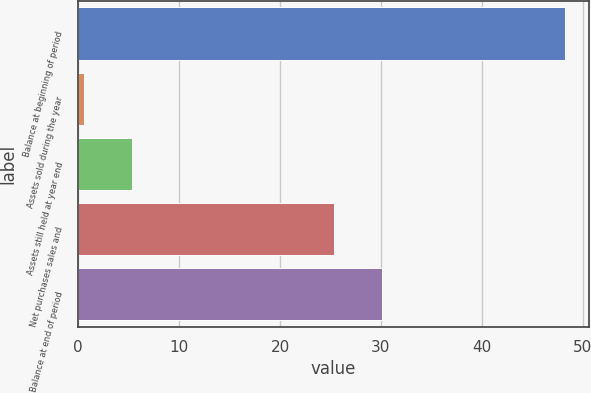Convert chart. <chart><loc_0><loc_0><loc_500><loc_500><bar_chart><fcel>Balance at beginning of period<fcel>Assets sold during the year<fcel>Assets still held at year end<fcel>Net purchases sales and<fcel>Balance at end of period<nl><fcel>48.2<fcel>0.6<fcel>5.36<fcel>25.3<fcel>30.06<nl></chart> 